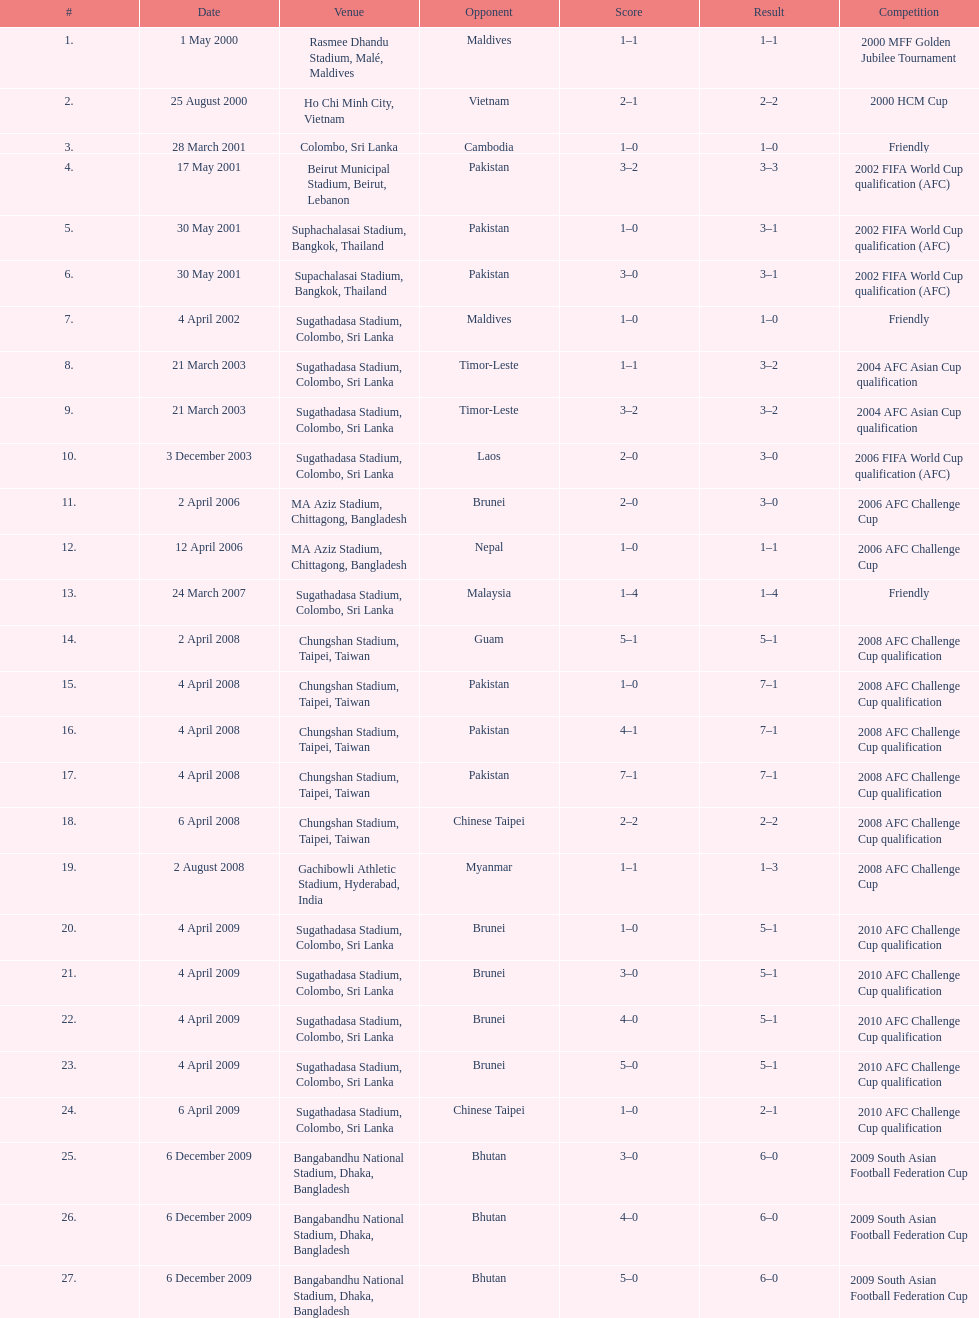In which month were more competitions conducted, april or december? April. 